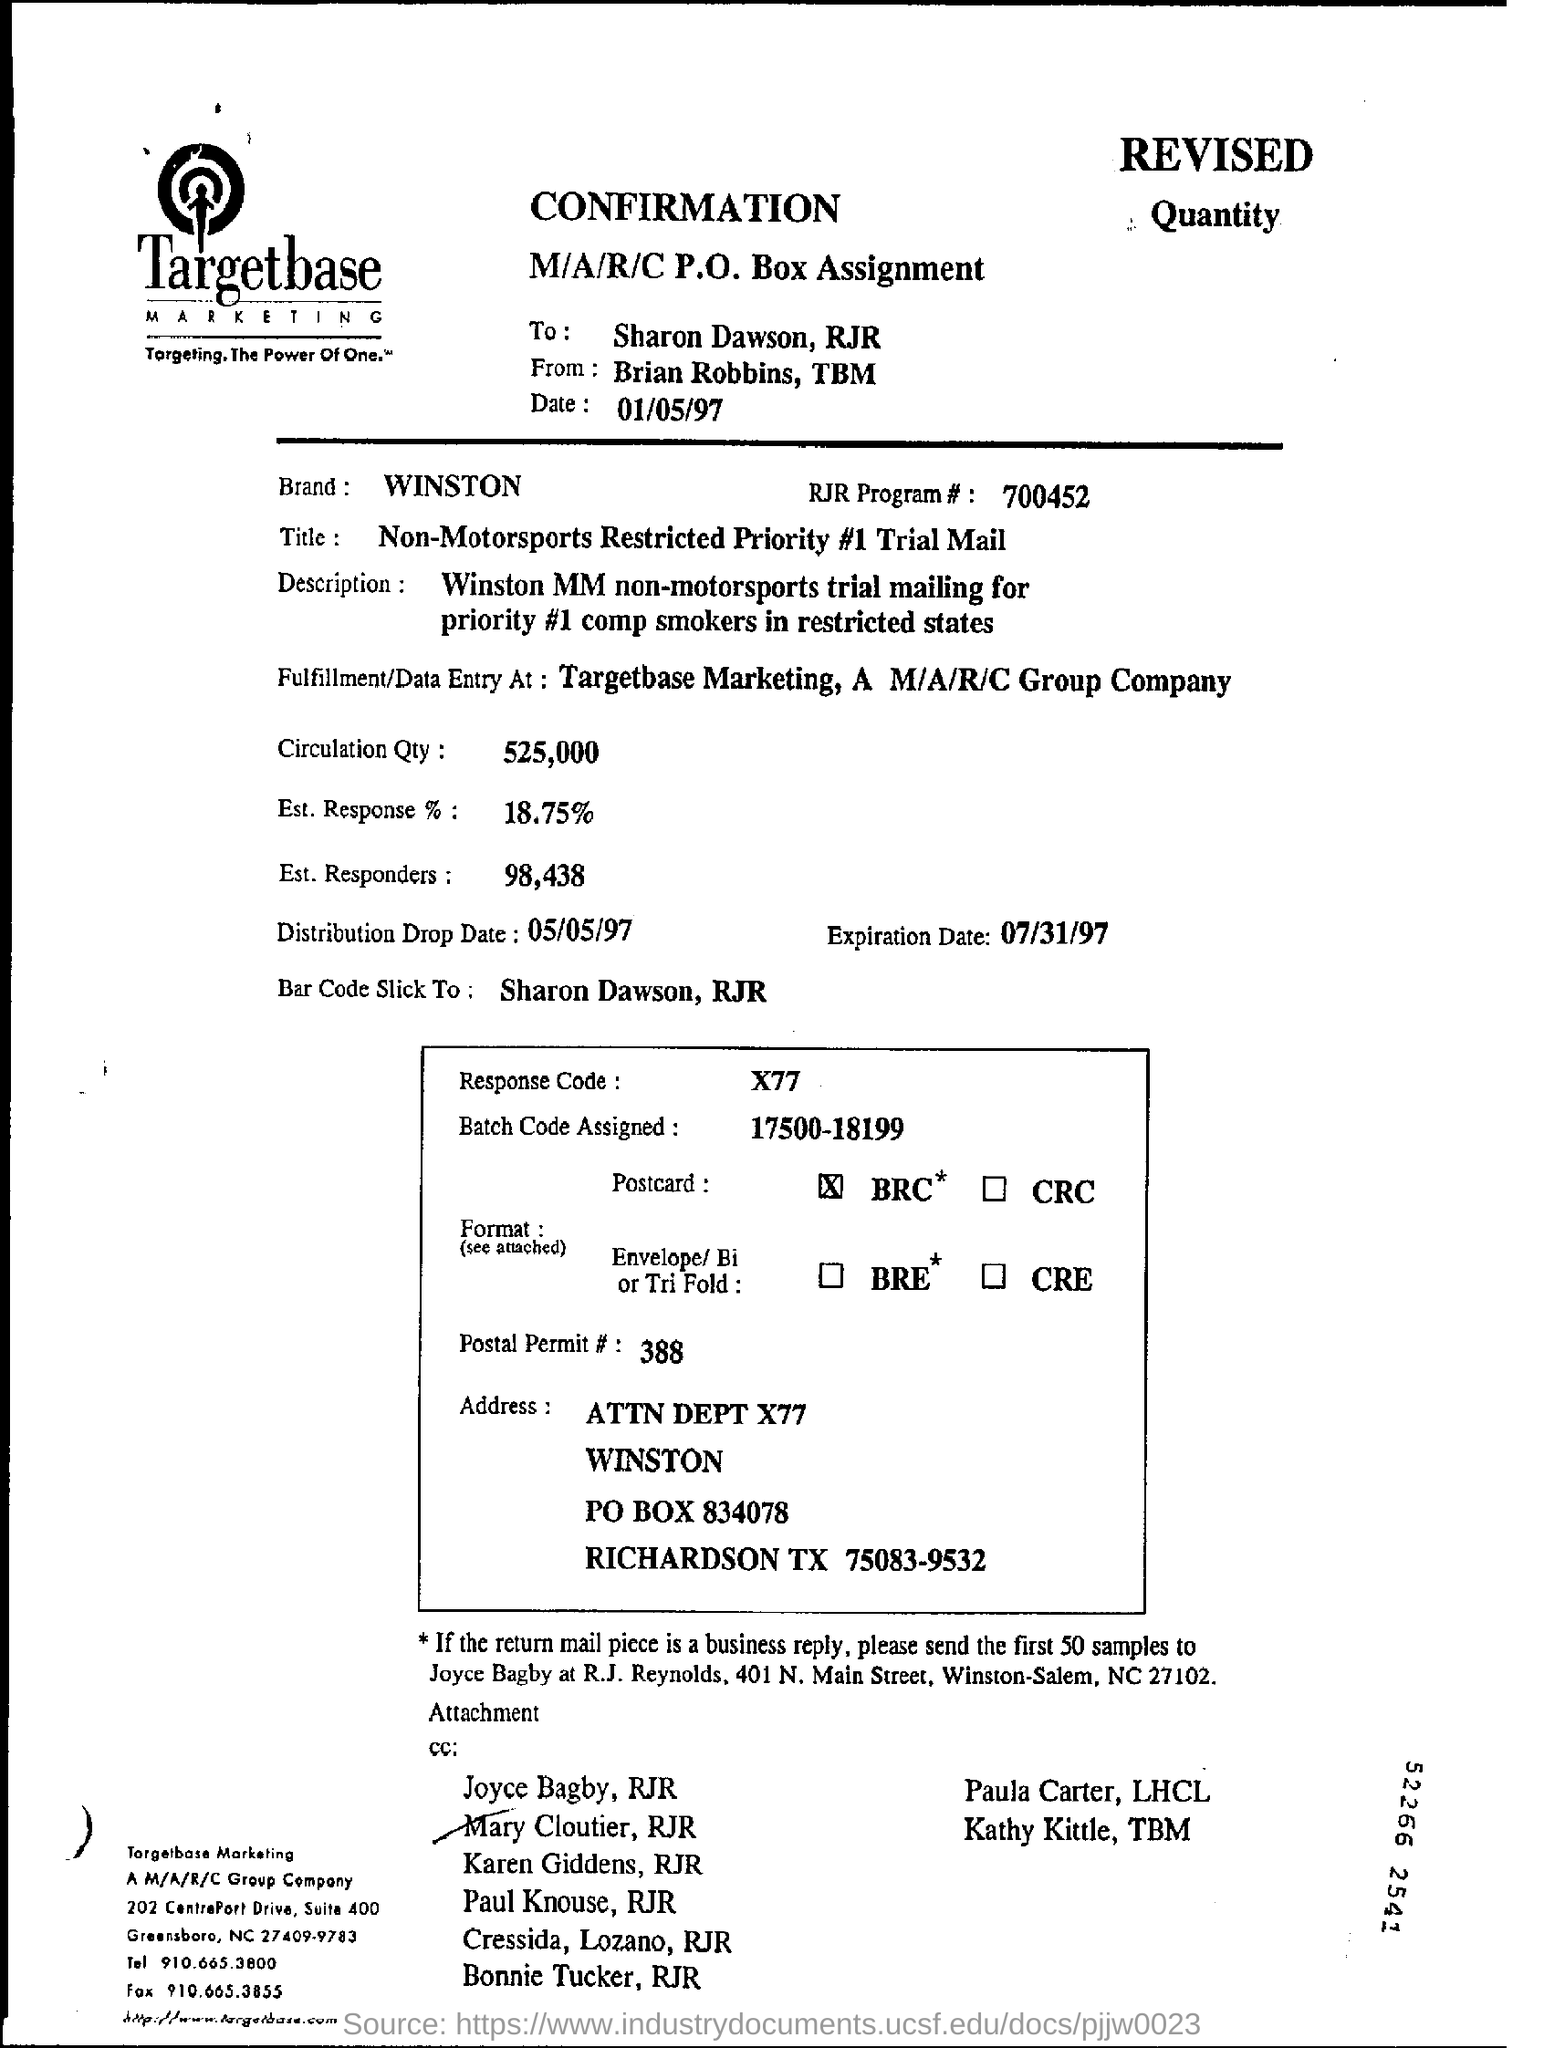List a handful of essential elements in this visual. The brand mentioned is WINSTON. The heading of the document is "CONFIRMATION. The expiration date is July 31, 1997. The distribution drop date is May 5, 1997. 